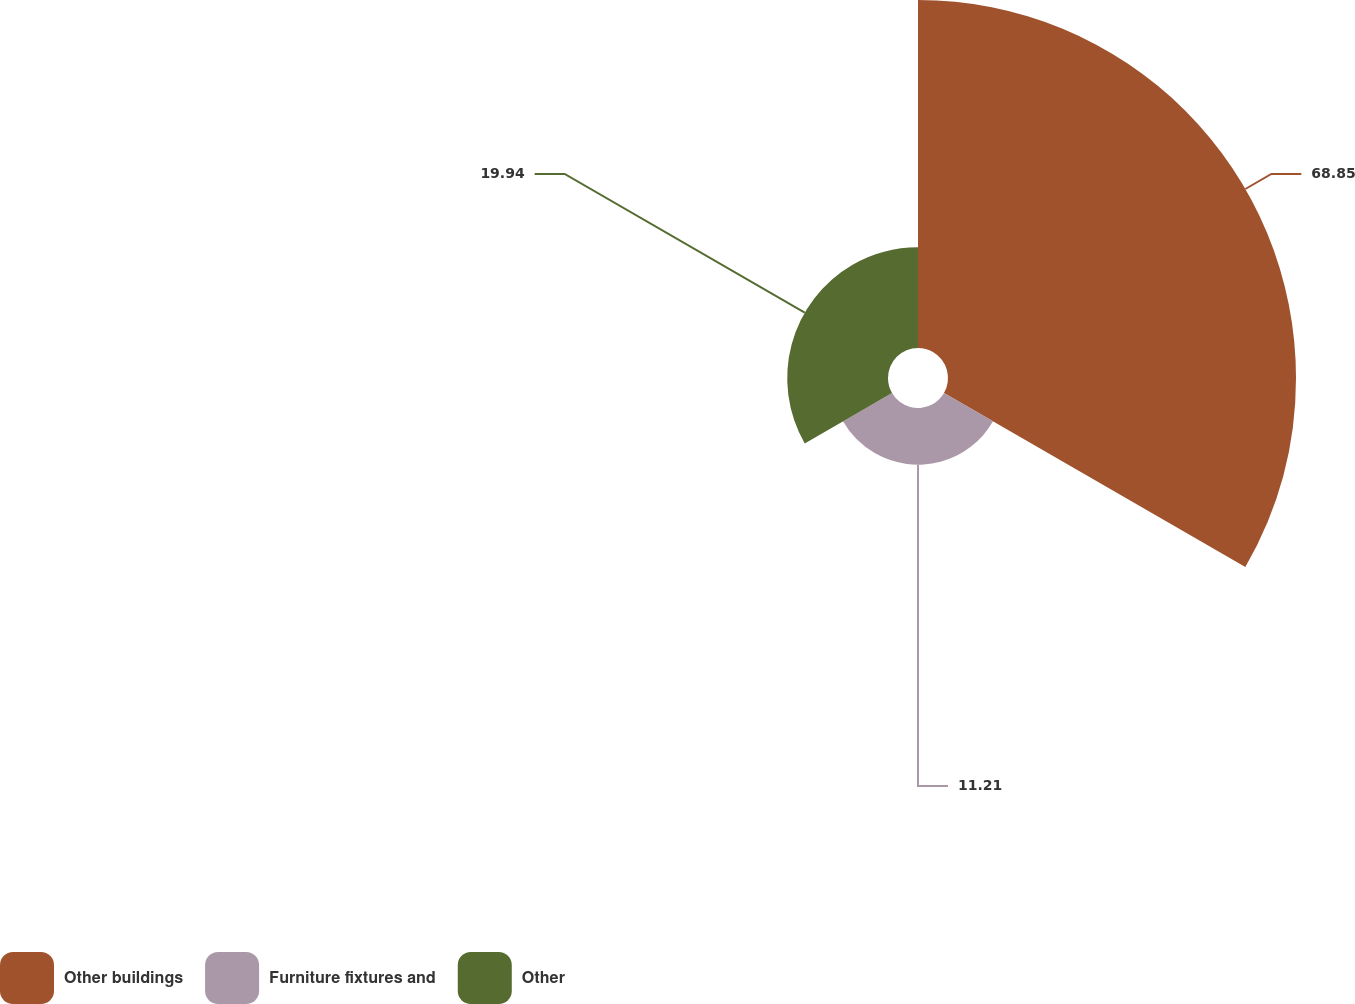Convert chart to OTSL. <chart><loc_0><loc_0><loc_500><loc_500><pie_chart><fcel>Other buildings<fcel>Furniture fixtures and<fcel>Other<nl><fcel>68.85%<fcel>11.21%<fcel>19.94%<nl></chart> 